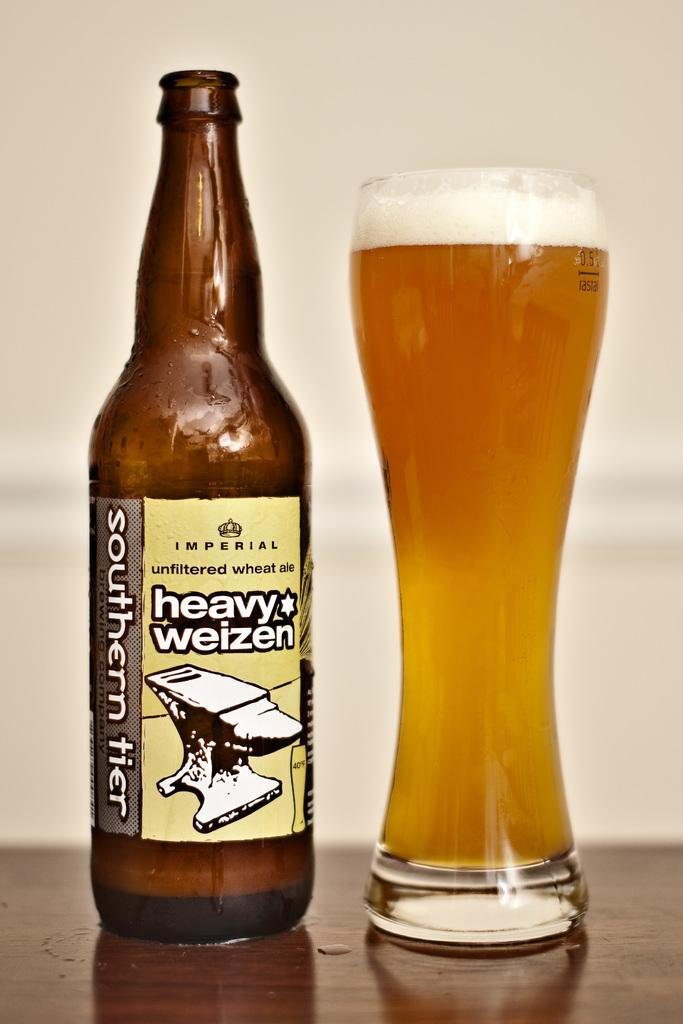<image>
Give a short and clear explanation of the subsequent image. a bottle of southern tier heavy weizen standing next to a glass full of it 